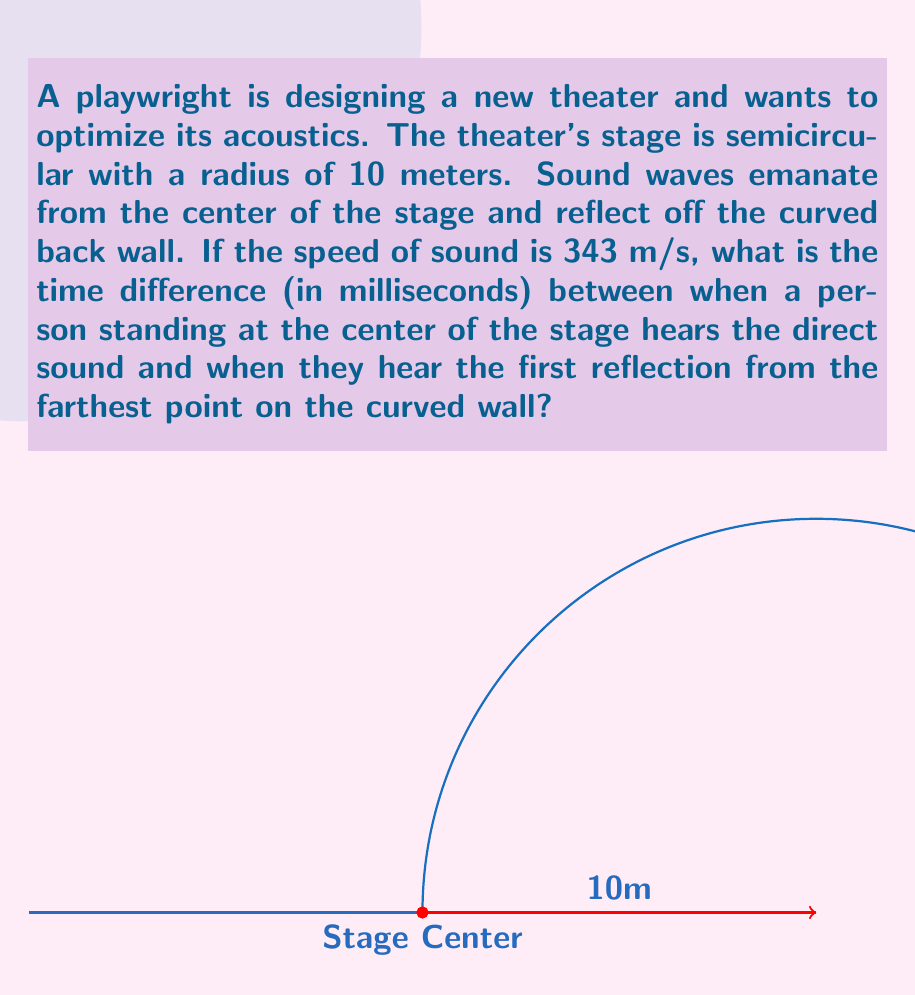Could you help me with this problem? Let's approach this step-by-step:

1) The direct sound travels from the center to the person instantly (they're at the same point), so its travel time is 0.

2) For the reflected sound, we need to calculate:
   a) The distance from the center to the farthest point on the wall
   b) The time it takes for the sound to travel this distance and back

3) The farthest point on a semicircle is at the ends of the diameter. The radius is 10m, so the diameter is 20m.

4) The distance the reflected sound travels is:
   $$\text{Distance} = 10\text{m} + 10\text{m} = 20\text{m}$$

5) To find the time, we use the formula:
   $$\text{Time} = \frac{\text{Distance}}{\text{Speed}}$$

6) Plugging in our values:
   $$\text{Time} = \frac{20\text{m}}{343\text{m/s}} \approx 0.0583\text{s}$$

7) Convert this to milliseconds:
   $$0.0583\text{s} \times 1000 = 58.3\text{ms}$$

8) The time difference is just this time, as the direct sound takes 0 time.
Answer: 58.3 ms 